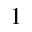Convert formula to latex. <formula><loc_0><loc_0><loc_500><loc_500>1</formula> 